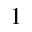Convert formula to latex. <formula><loc_0><loc_0><loc_500><loc_500>1</formula> 